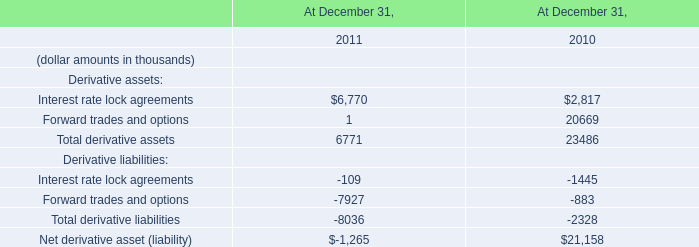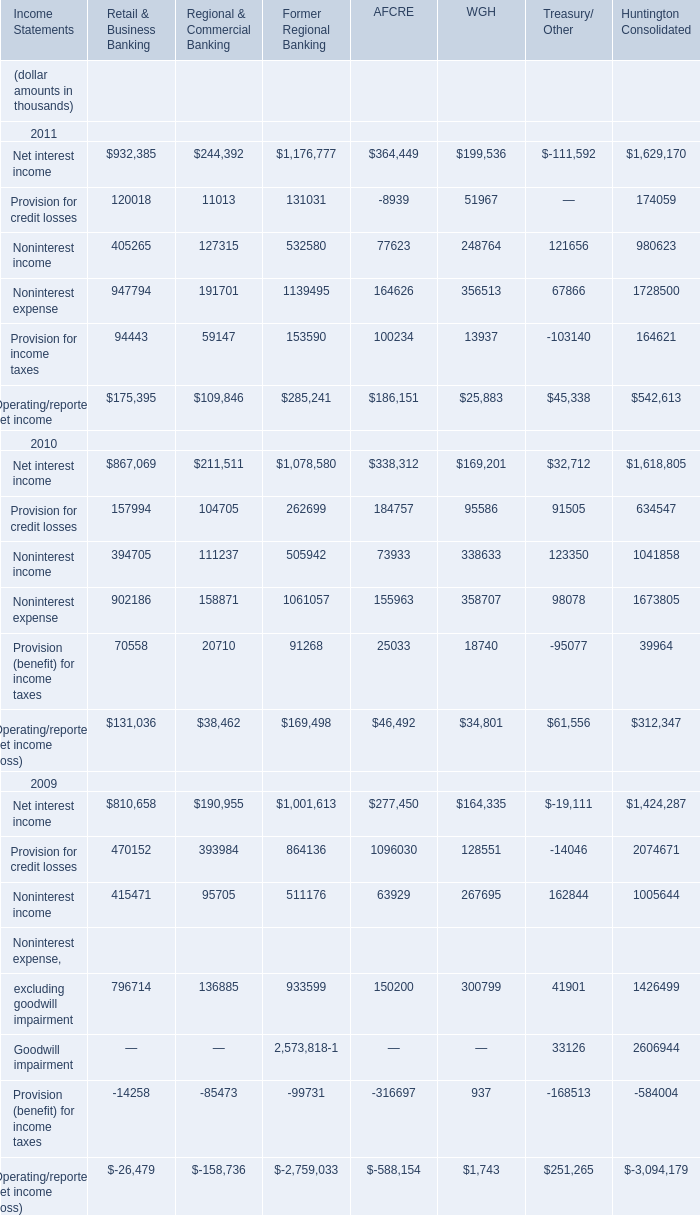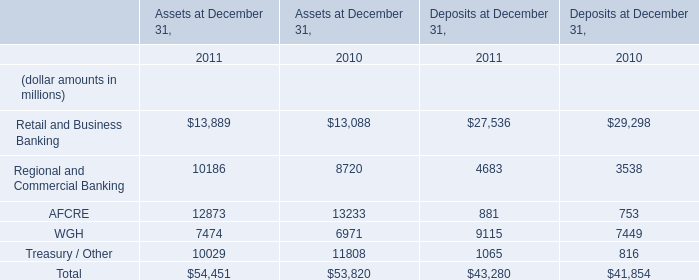If WGH develops with the same increasing rate in Assets at December 31,2011, what will it reach in 2012? (in million) 
Computations: ((((7474 - 6971) / 6971) + 1) * 7474)
Answer: 8013.29451. 